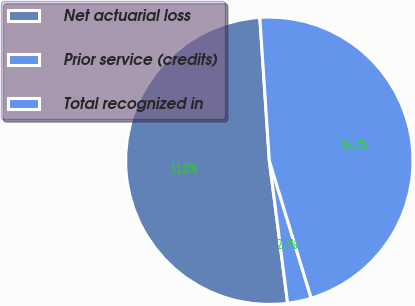Convert chart to OTSL. <chart><loc_0><loc_0><loc_500><loc_500><pie_chart><fcel>Net actuarial loss<fcel>Prior service (credits)<fcel>Total recognized in<nl><fcel>50.98%<fcel>2.67%<fcel>46.35%<nl></chart> 